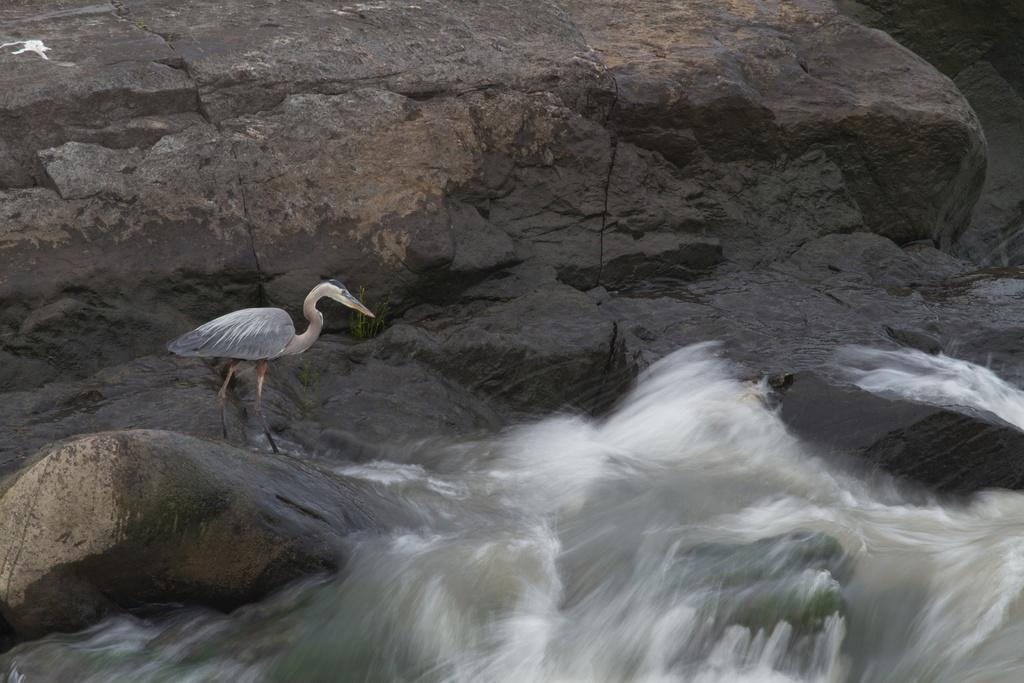What type of animal can be seen in the image? There is a bird in the image. Can you describe the bird's coloring? The bird is black, white, and cream in color. What is the bird standing on in the image? The bird is standing on a rock. What else can be seen in the image besides the bird? There is water visible in the image, and there is a large rock surface. What type of drum can be seen in the image? There is no drum present in the image; it features a bird standing on a rock with water and a large rock surface visible. Are there any plantations visible in the image? There is no plantation present in the image; it features a bird standing on a rock with water and a large rock surface visible. 